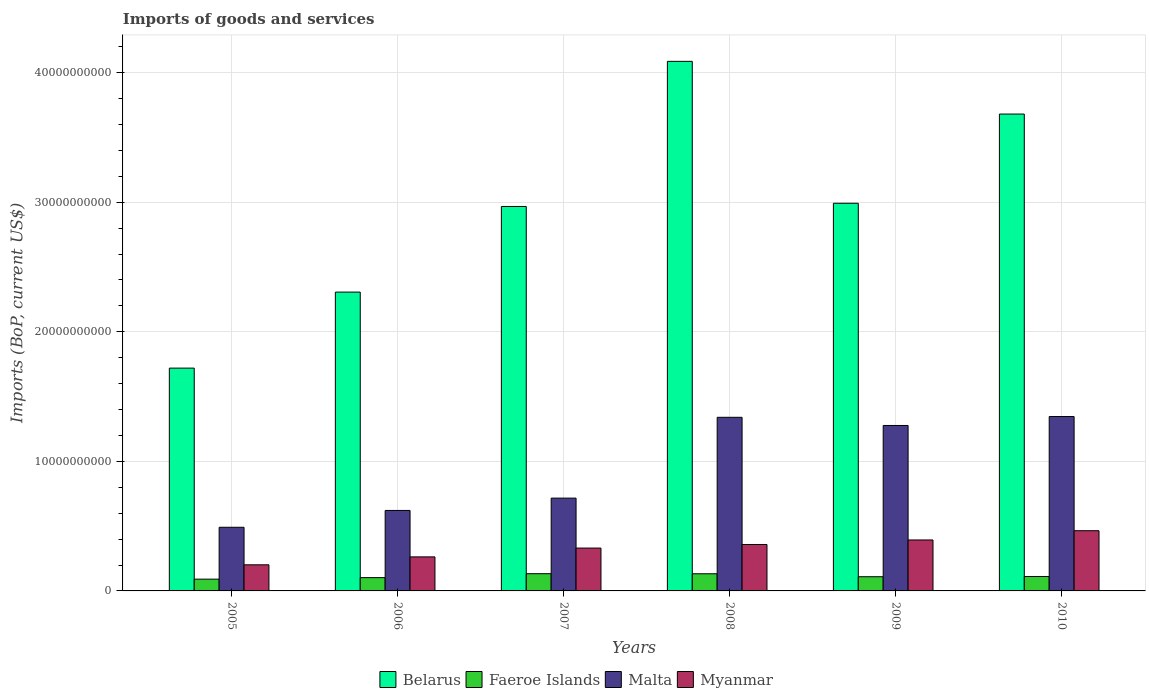How many different coloured bars are there?
Ensure brevity in your answer.  4. How many groups of bars are there?
Your answer should be very brief. 6. What is the label of the 6th group of bars from the left?
Your answer should be very brief. 2010. What is the amount spent on imports in Faeroe Islands in 2005?
Provide a short and direct response. 9.09e+08. Across all years, what is the maximum amount spent on imports in Faeroe Islands?
Your response must be concise. 1.33e+09. Across all years, what is the minimum amount spent on imports in Malta?
Give a very brief answer. 4.91e+09. In which year was the amount spent on imports in Malta maximum?
Provide a succinct answer. 2010. In which year was the amount spent on imports in Belarus minimum?
Your answer should be very brief. 2005. What is the total amount spent on imports in Myanmar in the graph?
Your answer should be compact. 2.01e+1. What is the difference between the amount spent on imports in Malta in 2005 and that in 2008?
Keep it short and to the point. -8.49e+09. What is the difference between the amount spent on imports in Myanmar in 2010 and the amount spent on imports in Malta in 2006?
Give a very brief answer. -1.56e+09. What is the average amount spent on imports in Belarus per year?
Make the answer very short. 2.96e+1. In the year 2006, what is the difference between the amount spent on imports in Myanmar and amount spent on imports in Faeroe Islands?
Ensure brevity in your answer.  1.60e+09. In how many years, is the amount spent on imports in Malta greater than 14000000000 US$?
Keep it short and to the point. 0. What is the ratio of the amount spent on imports in Malta in 2007 to that in 2009?
Ensure brevity in your answer.  0.56. Is the amount spent on imports in Belarus in 2007 less than that in 2010?
Your response must be concise. Yes. Is the difference between the amount spent on imports in Myanmar in 2008 and 2010 greater than the difference between the amount spent on imports in Faeroe Islands in 2008 and 2010?
Your response must be concise. No. What is the difference between the highest and the second highest amount spent on imports in Malta?
Provide a succinct answer. 5.88e+07. What is the difference between the highest and the lowest amount spent on imports in Myanmar?
Your answer should be very brief. 2.63e+09. Is it the case that in every year, the sum of the amount spent on imports in Belarus and amount spent on imports in Faeroe Islands is greater than the sum of amount spent on imports in Myanmar and amount spent on imports in Malta?
Ensure brevity in your answer.  Yes. What does the 2nd bar from the left in 2009 represents?
Your response must be concise. Faeroe Islands. What does the 1st bar from the right in 2005 represents?
Make the answer very short. Myanmar. How many bars are there?
Offer a very short reply. 24. Are the values on the major ticks of Y-axis written in scientific E-notation?
Provide a succinct answer. No. Does the graph contain any zero values?
Give a very brief answer. No. Does the graph contain grids?
Ensure brevity in your answer.  Yes. Where does the legend appear in the graph?
Provide a succinct answer. Bottom center. What is the title of the graph?
Ensure brevity in your answer.  Imports of goods and services. What is the label or title of the X-axis?
Provide a succinct answer. Years. What is the label or title of the Y-axis?
Provide a short and direct response. Imports (BoP, current US$). What is the Imports (BoP, current US$) of Belarus in 2005?
Give a very brief answer. 1.72e+1. What is the Imports (BoP, current US$) in Faeroe Islands in 2005?
Make the answer very short. 9.09e+08. What is the Imports (BoP, current US$) of Malta in 2005?
Offer a very short reply. 4.91e+09. What is the Imports (BoP, current US$) in Myanmar in 2005?
Provide a short and direct response. 2.02e+09. What is the Imports (BoP, current US$) in Belarus in 2006?
Make the answer very short. 2.31e+1. What is the Imports (BoP, current US$) of Faeroe Islands in 2006?
Your answer should be very brief. 1.03e+09. What is the Imports (BoP, current US$) of Malta in 2006?
Offer a very short reply. 6.21e+09. What is the Imports (BoP, current US$) in Myanmar in 2006?
Provide a succinct answer. 2.63e+09. What is the Imports (BoP, current US$) in Belarus in 2007?
Provide a succinct answer. 2.97e+1. What is the Imports (BoP, current US$) in Faeroe Islands in 2007?
Your response must be concise. 1.33e+09. What is the Imports (BoP, current US$) in Malta in 2007?
Provide a succinct answer. 7.16e+09. What is the Imports (BoP, current US$) in Myanmar in 2007?
Give a very brief answer. 3.31e+09. What is the Imports (BoP, current US$) of Belarus in 2008?
Your answer should be compact. 4.09e+1. What is the Imports (BoP, current US$) in Faeroe Islands in 2008?
Keep it short and to the point. 1.32e+09. What is the Imports (BoP, current US$) of Malta in 2008?
Give a very brief answer. 1.34e+1. What is the Imports (BoP, current US$) of Myanmar in 2008?
Keep it short and to the point. 3.58e+09. What is the Imports (BoP, current US$) of Belarus in 2009?
Give a very brief answer. 2.99e+1. What is the Imports (BoP, current US$) in Faeroe Islands in 2009?
Your answer should be very brief. 1.10e+09. What is the Imports (BoP, current US$) in Malta in 2009?
Your answer should be very brief. 1.28e+1. What is the Imports (BoP, current US$) of Myanmar in 2009?
Offer a terse response. 3.93e+09. What is the Imports (BoP, current US$) in Belarus in 2010?
Your answer should be very brief. 3.68e+1. What is the Imports (BoP, current US$) of Faeroe Islands in 2010?
Provide a succinct answer. 1.11e+09. What is the Imports (BoP, current US$) in Malta in 2010?
Your answer should be compact. 1.35e+1. What is the Imports (BoP, current US$) in Myanmar in 2010?
Your answer should be very brief. 4.65e+09. Across all years, what is the maximum Imports (BoP, current US$) of Belarus?
Provide a short and direct response. 4.09e+1. Across all years, what is the maximum Imports (BoP, current US$) of Faeroe Islands?
Your answer should be compact. 1.33e+09. Across all years, what is the maximum Imports (BoP, current US$) in Malta?
Provide a short and direct response. 1.35e+1. Across all years, what is the maximum Imports (BoP, current US$) in Myanmar?
Ensure brevity in your answer.  4.65e+09. Across all years, what is the minimum Imports (BoP, current US$) of Belarus?
Provide a short and direct response. 1.72e+1. Across all years, what is the minimum Imports (BoP, current US$) in Faeroe Islands?
Provide a short and direct response. 9.09e+08. Across all years, what is the minimum Imports (BoP, current US$) in Malta?
Make the answer very short. 4.91e+09. Across all years, what is the minimum Imports (BoP, current US$) in Myanmar?
Your response must be concise. 2.02e+09. What is the total Imports (BoP, current US$) of Belarus in the graph?
Your answer should be very brief. 1.78e+11. What is the total Imports (BoP, current US$) of Faeroe Islands in the graph?
Provide a succinct answer. 6.79e+09. What is the total Imports (BoP, current US$) in Malta in the graph?
Make the answer very short. 5.79e+1. What is the total Imports (BoP, current US$) in Myanmar in the graph?
Offer a very short reply. 2.01e+1. What is the difference between the Imports (BoP, current US$) of Belarus in 2005 and that in 2006?
Offer a terse response. -5.87e+09. What is the difference between the Imports (BoP, current US$) in Faeroe Islands in 2005 and that in 2006?
Provide a short and direct response. -1.17e+08. What is the difference between the Imports (BoP, current US$) in Malta in 2005 and that in 2006?
Your response must be concise. -1.30e+09. What is the difference between the Imports (BoP, current US$) in Myanmar in 2005 and that in 2006?
Your answer should be very brief. -6.11e+08. What is the difference between the Imports (BoP, current US$) in Belarus in 2005 and that in 2007?
Your answer should be very brief. -1.25e+1. What is the difference between the Imports (BoP, current US$) of Faeroe Islands in 2005 and that in 2007?
Your answer should be compact. -4.21e+08. What is the difference between the Imports (BoP, current US$) of Malta in 2005 and that in 2007?
Provide a short and direct response. -2.25e+09. What is the difference between the Imports (BoP, current US$) in Myanmar in 2005 and that in 2007?
Provide a succinct answer. -1.29e+09. What is the difference between the Imports (BoP, current US$) of Belarus in 2005 and that in 2008?
Your answer should be compact. -2.37e+1. What is the difference between the Imports (BoP, current US$) in Faeroe Islands in 2005 and that in 2008?
Provide a short and direct response. -4.15e+08. What is the difference between the Imports (BoP, current US$) of Malta in 2005 and that in 2008?
Your answer should be very brief. -8.49e+09. What is the difference between the Imports (BoP, current US$) in Myanmar in 2005 and that in 2008?
Your response must be concise. -1.57e+09. What is the difference between the Imports (BoP, current US$) of Belarus in 2005 and that in 2009?
Offer a very short reply. -1.27e+1. What is the difference between the Imports (BoP, current US$) of Faeroe Islands in 2005 and that in 2009?
Keep it short and to the point. -1.87e+08. What is the difference between the Imports (BoP, current US$) of Malta in 2005 and that in 2009?
Make the answer very short. -7.86e+09. What is the difference between the Imports (BoP, current US$) in Myanmar in 2005 and that in 2009?
Your answer should be compact. -1.92e+09. What is the difference between the Imports (BoP, current US$) in Belarus in 2005 and that in 2010?
Give a very brief answer. -1.96e+1. What is the difference between the Imports (BoP, current US$) in Faeroe Islands in 2005 and that in 2010?
Provide a short and direct response. -2.02e+08. What is the difference between the Imports (BoP, current US$) in Malta in 2005 and that in 2010?
Provide a short and direct response. -8.55e+09. What is the difference between the Imports (BoP, current US$) in Myanmar in 2005 and that in 2010?
Keep it short and to the point. -2.63e+09. What is the difference between the Imports (BoP, current US$) of Belarus in 2006 and that in 2007?
Keep it short and to the point. -6.61e+09. What is the difference between the Imports (BoP, current US$) in Faeroe Islands in 2006 and that in 2007?
Keep it short and to the point. -3.04e+08. What is the difference between the Imports (BoP, current US$) of Malta in 2006 and that in 2007?
Offer a very short reply. -9.52e+08. What is the difference between the Imports (BoP, current US$) of Myanmar in 2006 and that in 2007?
Offer a terse response. -6.80e+08. What is the difference between the Imports (BoP, current US$) in Belarus in 2006 and that in 2008?
Provide a short and direct response. -1.78e+1. What is the difference between the Imports (BoP, current US$) in Faeroe Islands in 2006 and that in 2008?
Offer a very short reply. -2.98e+08. What is the difference between the Imports (BoP, current US$) of Malta in 2006 and that in 2008?
Your answer should be very brief. -7.19e+09. What is the difference between the Imports (BoP, current US$) of Myanmar in 2006 and that in 2008?
Offer a terse response. -9.56e+08. What is the difference between the Imports (BoP, current US$) in Belarus in 2006 and that in 2009?
Offer a terse response. -6.86e+09. What is the difference between the Imports (BoP, current US$) of Faeroe Islands in 2006 and that in 2009?
Your response must be concise. -6.97e+07. What is the difference between the Imports (BoP, current US$) in Malta in 2006 and that in 2009?
Make the answer very short. -6.56e+09. What is the difference between the Imports (BoP, current US$) of Myanmar in 2006 and that in 2009?
Your answer should be compact. -1.31e+09. What is the difference between the Imports (BoP, current US$) of Belarus in 2006 and that in 2010?
Keep it short and to the point. -1.37e+1. What is the difference between the Imports (BoP, current US$) in Faeroe Islands in 2006 and that in 2010?
Ensure brevity in your answer.  -8.53e+07. What is the difference between the Imports (BoP, current US$) of Malta in 2006 and that in 2010?
Ensure brevity in your answer.  -7.25e+09. What is the difference between the Imports (BoP, current US$) of Myanmar in 2006 and that in 2010?
Keep it short and to the point. -2.02e+09. What is the difference between the Imports (BoP, current US$) in Belarus in 2007 and that in 2008?
Your answer should be very brief. -1.12e+1. What is the difference between the Imports (BoP, current US$) of Faeroe Islands in 2007 and that in 2008?
Offer a terse response. 6.06e+06. What is the difference between the Imports (BoP, current US$) of Malta in 2007 and that in 2008?
Give a very brief answer. -6.24e+09. What is the difference between the Imports (BoP, current US$) in Myanmar in 2007 and that in 2008?
Ensure brevity in your answer.  -2.76e+08. What is the difference between the Imports (BoP, current US$) of Belarus in 2007 and that in 2009?
Give a very brief answer. -2.49e+08. What is the difference between the Imports (BoP, current US$) in Faeroe Islands in 2007 and that in 2009?
Your answer should be compact. 2.35e+08. What is the difference between the Imports (BoP, current US$) of Malta in 2007 and that in 2009?
Offer a very short reply. -5.61e+09. What is the difference between the Imports (BoP, current US$) in Myanmar in 2007 and that in 2009?
Offer a very short reply. -6.26e+08. What is the difference between the Imports (BoP, current US$) in Belarus in 2007 and that in 2010?
Your answer should be very brief. -7.13e+09. What is the difference between the Imports (BoP, current US$) of Faeroe Islands in 2007 and that in 2010?
Provide a short and direct response. 2.19e+08. What is the difference between the Imports (BoP, current US$) of Malta in 2007 and that in 2010?
Provide a short and direct response. -6.30e+09. What is the difference between the Imports (BoP, current US$) in Myanmar in 2007 and that in 2010?
Keep it short and to the point. -1.34e+09. What is the difference between the Imports (BoP, current US$) of Belarus in 2008 and that in 2009?
Your response must be concise. 1.10e+1. What is the difference between the Imports (BoP, current US$) in Faeroe Islands in 2008 and that in 2009?
Offer a terse response. 2.29e+08. What is the difference between the Imports (BoP, current US$) in Malta in 2008 and that in 2009?
Offer a terse response. 6.31e+08. What is the difference between the Imports (BoP, current US$) of Myanmar in 2008 and that in 2009?
Your response must be concise. -3.50e+08. What is the difference between the Imports (BoP, current US$) of Belarus in 2008 and that in 2010?
Your answer should be compact. 4.07e+09. What is the difference between the Imports (BoP, current US$) in Faeroe Islands in 2008 and that in 2010?
Give a very brief answer. 2.13e+08. What is the difference between the Imports (BoP, current US$) in Malta in 2008 and that in 2010?
Ensure brevity in your answer.  -5.88e+07. What is the difference between the Imports (BoP, current US$) in Myanmar in 2008 and that in 2010?
Give a very brief answer. -1.06e+09. What is the difference between the Imports (BoP, current US$) of Belarus in 2009 and that in 2010?
Your answer should be compact. -6.88e+09. What is the difference between the Imports (BoP, current US$) in Faeroe Islands in 2009 and that in 2010?
Offer a terse response. -1.55e+07. What is the difference between the Imports (BoP, current US$) of Malta in 2009 and that in 2010?
Provide a succinct answer. -6.89e+08. What is the difference between the Imports (BoP, current US$) of Myanmar in 2009 and that in 2010?
Keep it short and to the point. -7.14e+08. What is the difference between the Imports (BoP, current US$) of Belarus in 2005 and the Imports (BoP, current US$) of Faeroe Islands in 2006?
Keep it short and to the point. 1.62e+1. What is the difference between the Imports (BoP, current US$) of Belarus in 2005 and the Imports (BoP, current US$) of Malta in 2006?
Provide a short and direct response. 1.10e+1. What is the difference between the Imports (BoP, current US$) in Belarus in 2005 and the Imports (BoP, current US$) in Myanmar in 2006?
Keep it short and to the point. 1.46e+1. What is the difference between the Imports (BoP, current US$) in Faeroe Islands in 2005 and the Imports (BoP, current US$) in Malta in 2006?
Offer a very short reply. -5.30e+09. What is the difference between the Imports (BoP, current US$) in Faeroe Islands in 2005 and the Imports (BoP, current US$) in Myanmar in 2006?
Keep it short and to the point. -1.72e+09. What is the difference between the Imports (BoP, current US$) in Malta in 2005 and the Imports (BoP, current US$) in Myanmar in 2006?
Give a very brief answer. 2.29e+09. What is the difference between the Imports (BoP, current US$) of Belarus in 2005 and the Imports (BoP, current US$) of Faeroe Islands in 2007?
Your response must be concise. 1.59e+1. What is the difference between the Imports (BoP, current US$) in Belarus in 2005 and the Imports (BoP, current US$) in Malta in 2007?
Your answer should be compact. 1.00e+1. What is the difference between the Imports (BoP, current US$) of Belarus in 2005 and the Imports (BoP, current US$) of Myanmar in 2007?
Make the answer very short. 1.39e+1. What is the difference between the Imports (BoP, current US$) in Faeroe Islands in 2005 and the Imports (BoP, current US$) in Malta in 2007?
Provide a short and direct response. -6.25e+09. What is the difference between the Imports (BoP, current US$) of Faeroe Islands in 2005 and the Imports (BoP, current US$) of Myanmar in 2007?
Offer a very short reply. -2.40e+09. What is the difference between the Imports (BoP, current US$) of Malta in 2005 and the Imports (BoP, current US$) of Myanmar in 2007?
Your answer should be compact. 1.61e+09. What is the difference between the Imports (BoP, current US$) of Belarus in 2005 and the Imports (BoP, current US$) of Faeroe Islands in 2008?
Provide a succinct answer. 1.59e+1. What is the difference between the Imports (BoP, current US$) in Belarus in 2005 and the Imports (BoP, current US$) in Malta in 2008?
Offer a terse response. 3.80e+09. What is the difference between the Imports (BoP, current US$) of Belarus in 2005 and the Imports (BoP, current US$) of Myanmar in 2008?
Offer a terse response. 1.36e+1. What is the difference between the Imports (BoP, current US$) in Faeroe Islands in 2005 and the Imports (BoP, current US$) in Malta in 2008?
Your response must be concise. -1.25e+1. What is the difference between the Imports (BoP, current US$) of Faeroe Islands in 2005 and the Imports (BoP, current US$) of Myanmar in 2008?
Offer a very short reply. -2.67e+09. What is the difference between the Imports (BoP, current US$) in Malta in 2005 and the Imports (BoP, current US$) in Myanmar in 2008?
Offer a terse response. 1.33e+09. What is the difference between the Imports (BoP, current US$) of Belarus in 2005 and the Imports (BoP, current US$) of Faeroe Islands in 2009?
Make the answer very short. 1.61e+1. What is the difference between the Imports (BoP, current US$) in Belarus in 2005 and the Imports (BoP, current US$) in Malta in 2009?
Your answer should be compact. 4.43e+09. What is the difference between the Imports (BoP, current US$) in Belarus in 2005 and the Imports (BoP, current US$) in Myanmar in 2009?
Keep it short and to the point. 1.33e+1. What is the difference between the Imports (BoP, current US$) of Faeroe Islands in 2005 and the Imports (BoP, current US$) of Malta in 2009?
Your response must be concise. -1.19e+1. What is the difference between the Imports (BoP, current US$) of Faeroe Islands in 2005 and the Imports (BoP, current US$) of Myanmar in 2009?
Provide a succinct answer. -3.02e+09. What is the difference between the Imports (BoP, current US$) of Malta in 2005 and the Imports (BoP, current US$) of Myanmar in 2009?
Keep it short and to the point. 9.80e+08. What is the difference between the Imports (BoP, current US$) of Belarus in 2005 and the Imports (BoP, current US$) of Faeroe Islands in 2010?
Your answer should be compact. 1.61e+1. What is the difference between the Imports (BoP, current US$) of Belarus in 2005 and the Imports (BoP, current US$) of Malta in 2010?
Keep it short and to the point. 3.74e+09. What is the difference between the Imports (BoP, current US$) in Belarus in 2005 and the Imports (BoP, current US$) in Myanmar in 2010?
Make the answer very short. 1.25e+1. What is the difference between the Imports (BoP, current US$) in Faeroe Islands in 2005 and the Imports (BoP, current US$) in Malta in 2010?
Give a very brief answer. -1.25e+1. What is the difference between the Imports (BoP, current US$) of Faeroe Islands in 2005 and the Imports (BoP, current US$) of Myanmar in 2010?
Provide a short and direct response. -3.74e+09. What is the difference between the Imports (BoP, current US$) in Malta in 2005 and the Imports (BoP, current US$) in Myanmar in 2010?
Your answer should be very brief. 2.66e+08. What is the difference between the Imports (BoP, current US$) of Belarus in 2006 and the Imports (BoP, current US$) of Faeroe Islands in 2007?
Provide a succinct answer. 2.17e+1. What is the difference between the Imports (BoP, current US$) in Belarus in 2006 and the Imports (BoP, current US$) in Malta in 2007?
Your answer should be compact. 1.59e+1. What is the difference between the Imports (BoP, current US$) in Belarus in 2006 and the Imports (BoP, current US$) in Myanmar in 2007?
Provide a short and direct response. 1.98e+1. What is the difference between the Imports (BoP, current US$) of Faeroe Islands in 2006 and the Imports (BoP, current US$) of Malta in 2007?
Your answer should be very brief. -6.14e+09. What is the difference between the Imports (BoP, current US$) in Faeroe Islands in 2006 and the Imports (BoP, current US$) in Myanmar in 2007?
Give a very brief answer. -2.28e+09. What is the difference between the Imports (BoP, current US$) in Malta in 2006 and the Imports (BoP, current US$) in Myanmar in 2007?
Offer a terse response. 2.90e+09. What is the difference between the Imports (BoP, current US$) of Belarus in 2006 and the Imports (BoP, current US$) of Faeroe Islands in 2008?
Ensure brevity in your answer.  2.17e+1. What is the difference between the Imports (BoP, current US$) of Belarus in 2006 and the Imports (BoP, current US$) of Malta in 2008?
Your answer should be compact. 9.66e+09. What is the difference between the Imports (BoP, current US$) of Belarus in 2006 and the Imports (BoP, current US$) of Myanmar in 2008?
Provide a succinct answer. 1.95e+1. What is the difference between the Imports (BoP, current US$) in Faeroe Islands in 2006 and the Imports (BoP, current US$) in Malta in 2008?
Offer a terse response. -1.24e+1. What is the difference between the Imports (BoP, current US$) of Faeroe Islands in 2006 and the Imports (BoP, current US$) of Myanmar in 2008?
Offer a terse response. -2.56e+09. What is the difference between the Imports (BoP, current US$) in Malta in 2006 and the Imports (BoP, current US$) in Myanmar in 2008?
Provide a succinct answer. 2.63e+09. What is the difference between the Imports (BoP, current US$) of Belarus in 2006 and the Imports (BoP, current US$) of Faeroe Islands in 2009?
Your response must be concise. 2.20e+1. What is the difference between the Imports (BoP, current US$) of Belarus in 2006 and the Imports (BoP, current US$) of Malta in 2009?
Give a very brief answer. 1.03e+1. What is the difference between the Imports (BoP, current US$) in Belarus in 2006 and the Imports (BoP, current US$) in Myanmar in 2009?
Your answer should be compact. 1.91e+1. What is the difference between the Imports (BoP, current US$) in Faeroe Islands in 2006 and the Imports (BoP, current US$) in Malta in 2009?
Offer a terse response. -1.17e+1. What is the difference between the Imports (BoP, current US$) in Faeroe Islands in 2006 and the Imports (BoP, current US$) in Myanmar in 2009?
Make the answer very short. -2.91e+09. What is the difference between the Imports (BoP, current US$) of Malta in 2006 and the Imports (BoP, current US$) of Myanmar in 2009?
Provide a succinct answer. 2.28e+09. What is the difference between the Imports (BoP, current US$) of Belarus in 2006 and the Imports (BoP, current US$) of Faeroe Islands in 2010?
Offer a terse response. 2.20e+1. What is the difference between the Imports (BoP, current US$) in Belarus in 2006 and the Imports (BoP, current US$) in Malta in 2010?
Your answer should be very brief. 9.60e+09. What is the difference between the Imports (BoP, current US$) in Belarus in 2006 and the Imports (BoP, current US$) in Myanmar in 2010?
Offer a very short reply. 1.84e+1. What is the difference between the Imports (BoP, current US$) of Faeroe Islands in 2006 and the Imports (BoP, current US$) of Malta in 2010?
Provide a succinct answer. -1.24e+1. What is the difference between the Imports (BoP, current US$) in Faeroe Islands in 2006 and the Imports (BoP, current US$) in Myanmar in 2010?
Your answer should be very brief. -3.62e+09. What is the difference between the Imports (BoP, current US$) of Malta in 2006 and the Imports (BoP, current US$) of Myanmar in 2010?
Ensure brevity in your answer.  1.56e+09. What is the difference between the Imports (BoP, current US$) of Belarus in 2007 and the Imports (BoP, current US$) of Faeroe Islands in 2008?
Give a very brief answer. 2.83e+1. What is the difference between the Imports (BoP, current US$) of Belarus in 2007 and the Imports (BoP, current US$) of Malta in 2008?
Make the answer very short. 1.63e+1. What is the difference between the Imports (BoP, current US$) in Belarus in 2007 and the Imports (BoP, current US$) in Myanmar in 2008?
Provide a short and direct response. 2.61e+1. What is the difference between the Imports (BoP, current US$) in Faeroe Islands in 2007 and the Imports (BoP, current US$) in Malta in 2008?
Provide a succinct answer. -1.21e+1. What is the difference between the Imports (BoP, current US$) in Faeroe Islands in 2007 and the Imports (BoP, current US$) in Myanmar in 2008?
Your response must be concise. -2.25e+09. What is the difference between the Imports (BoP, current US$) of Malta in 2007 and the Imports (BoP, current US$) of Myanmar in 2008?
Provide a succinct answer. 3.58e+09. What is the difference between the Imports (BoP, current US$) of Belarus in 2007 and the Imports (BoP, current US$) of Faeroe Islands in 2009?
Offer a very short reply. 2.86e+1. What is the difference between the Imports (BoP, current US$) in Belarus in 2007 and the Imports (BoP, current US$) in Malta in 2009?
Give a very brief answer. 1.69e+1. What is the difference between the Imports (BoP, current US$) of Belarus in 2007 and the Imports (BoP, current US$) of Myanmar in 2009?
Your response must be concise. 2.57e+1. What is the difference between the Imports (BoP, current US$) in Faeroe Islands in 2007 and the Imports (BoP, current US$) in Malta in 2009?
Offer a very short reply. -1.14e+1. What is the difference between the Imports (BoP, current US$) in Faeroe Islands in 2007 and the Imports (BoP, current US$) in Myanmar in 2009?
Give a very brief answer. -2.60e+09. What is the difference between the Imports (BoP, current US$) of Malta in 2007 and the Imports (BoP, current US$) of Myanmar in 2009?
Ensure brevity in your answer.  3.23e+09. What is the difference between the Imports (BoP, current US$) in Belarus in 2007 and the Imports (BoP, current US$) in Faeroe Islands in 2010?
Provide a succinct answer. 2.86e+1. What is the difference between the Imports (BoP, current US$) of Belarus in 2007 and the Imports (BoP, current US$) of Malta in 2010?
Provide a succinct answer. 1.62e+1. What is the difference between the Imports (BoP, current US$) in Belarus in 2007 and the Imports (BoP, current US$) in Myanmar in 2010?
Keep it short and to the point. 2.50e+1. What is the difference between the Imports (BoP, current US$) of Faeroe Islands in 2007 and the Imports (BoP, current US$) of Malta in 2010?
Your response must be concise. -1.21e+1. What is the difference between the Imports (BoP, current US$) of Faeroe Islands in 2007 and the Imports (BoP, current US$) of Myanmar in 2010?
Offer a terse response. -3.32e+09. What is the difference between the Imports (BoP, current US$) of Malta in 2007 and the Imports (BoP, current US$) of Myanmar in 2010?
Make the answer very short. 2.52e+09. What is the difference between the Imports (BoP, current US$) of Belarus in 2008 and the Imports (BoP, current US$) of Faeroe Islands in 2009?
Provide a short and direct response. 3.98e+1. What is the difference between the Imports (BoP, current US$) in Belarus in 2008 and the Imports (BoP, current US$) in Malta in 2009?
Keep it short and to the point. 2.81e+1. What is the difference between the Imports (BoP, current US$) of Belarus in 2008 and the Imports (BoP, current US$) of Myanmar in 2009?
Make the answer very short. 3.69e+1. What is the difference between the Imports (BoP, current US$) in Faeroe Islands in 2008 and the Imports (BoP, current US$) in Malta in 2009?
Offer a terse response. -1.14e+1. What is the difference between the Imports (BoP, current US$) of Faeroe Islands in 2008 and the Imports (BoP, current US$) of Myanmar in 2009?
Make the answer very short. -2.61e+09. What is the difference between the Imports (BoP, current US$) in Malta in 2008 and the Imports (BoP, current US$) in Myanmar in 2009?
Your answer should be very brief. 9.47e+09. What is the difference between the Imports (BoP, current US$) in Belarus in 2008 and the Imports (BoP, current US$) in Faeroe Islands in 2010?
Provide a short and direct response. 3.98e+1. What is the difference between the Imports (BoP, current US$) of Belarus in 2008 and the Imports (BoP, current US$) of Malta in 2010?
Give a very brief answer. 2.74e+1. What is the difference between the Imports (BoP, current US$) in Belarus in 2008 and the Imports (BoP, current US$) in Myanmar in 2010?
Provide a short and direct response. 3.62e+1. What is the difference between the Imports (BoP, current US$) in Faeroe Islands in 2008 and the Imports (BoP, current US$) in Malta in 2010?
Your answer should be very brief. -1.21e+1. What is the difference between the Imports (BoP, current US$) in Faeroe Islands in 2008 and the Imports (BoP, current US$) in Myanmar in 2010?
Make the answer very short. -3.32e+09. What is the difference between the Imports (BoP, current US$) of Malta in 2008 and the Imports (BoP, current US$) of Myanmar in 2010?
Your response must be concise. 8.75e+09. What is the difference between the Imports (BoP, current US$) of Belarus in 2009 and the Imports (BoP, current US$) of Faeroe Islands in 2010?
Provide a short and direct response. 2.88e+1. What is the difference between the Imports (BoP, current US$) of Belarus in 2009 and the Imports (BoP, current US$) of Malta in 2010?
Ensure brevity in your answer.  1.65e+1. What is the difference between the Imports (BoP, current US$) in Belarus in 2009 and the Imports (BoP, current US$) in Myanmar in 2010?
Keep it short and to the point. 2.53e+1. What is the difference between the Imports (BoP, current US$) in Faeroe Islands in 2009 and the Imports (BoP, current US$) in Malta in 2010?
Ensure brevity in your answer.  -1.24e+1. What is the difference between the Imports (BoP, current US$) in Faeroe Islands in 2009 and the Imports (BoP, current US$) in Myanmar in 2010?
Give a very brief answer. -3.55e+09. What is the difference between the Imports (BoP, current US$) of Malta in 2009 and the Imports (BoP, current US$) of Myanmar in 2010?
Make the answer very short. 8.12e+09. What is the average Imports (BoP, current US$) of Belarus per year?
Your answer should be very brief. 2.96e+1. What is the average Imports (BoP, current US$) in Faeroe Islands per year?
Give a very brief answer. 1.13e+09. What is the average Imports (BoP, current US$) in Malta per year?
Your answer should be compact. 9.65e+09. What is the average Imports (BoP, current US$) of Myanmar per year?
Keep it short and to the point. 3.35e+09. In the year 2005, what is the difference between the Imports (BoP, current US$) in Belarus and Imports (BoP, current US$) in Faeroe Islands?
Offer a terse response. 1.63e+1. In the year 2005, what is the difference between the Imports (BoP, current US$) of Belarus and Imports (BoP, current US$) of Malta?
Make the answer very short. 1.23e+1. In the year 2005, what is the difference between the Imports (BoP, current US$) in Belarus and Imports (BoP, current US$) in Myanmar?
Provide a short and direct response. 1.52e+1. In the year 2005, what is the difference between the Imports (BoP, current US$) in Faeroe Islands and Imports (BoP, current US$) in Malta?
Your answer should be very brief. -4.00e+09. In the year 2005, what is the difference between the Imports (BoP, current US$) in Faeroe Islands and Imports (BoP, current US$) in Myanmar?
Your answer should be very brief. -1.11e+09. In the year 2005, what is the difference between the Imports (BoP, current US$) of Malta and Imports (BoP, current US$) of Myanmar?
Keep it short and to the point. 2.90e+09. In the year 2006, what is the difference between the Imports (BoP, current US$) of Belarus and Imports (BoP, current US$) of Faeroe Islands?
Your answer should be compact. 2.20e+1. In the year 2006, what is the difference between the Imports (BoP, current US$) in Belarus and Imports (BoP, current US$) in Malta?
Provide a succinct answer. 1.69e+1. In the year 2006, what is the difference between the Imports (BoP, current US$) of Belarus and Imports (BoP, current US$) of Myanmar?
Your answer should be compact. 2.04e+1. In the year 2006, what is the difference between the Imports (BoP, current US$) in Faeroe Islands and Imports (BoP, current US$) in Malta?
Provide a succinct answer. -5.18e+09. In the year 2006, what is the difference between the Imports (BoP, current US$) of Faeroe Islands and Imports (BoP, current US$) of Myanmar?
Keep it short and to the point. -1.60e+09. In the year 2006, what is the difference between the Imports (BoP, current US$) in Malta and Imports (BoP, current US$) in Myanmar?
Your answer should be compact. 3.58e+09. In the year 2007, what is the difference between the Imports (BoP, current US$) of Belarus and Imports (BoP, current US$) of Faeroe Islands?
Offer a very short reply. 2.83e+1. In the year 2007, what is the difference between the Imports (BoP, current US$) of Belarus and Imports (BoP, current US$) of Malta?
Offer a terse response. 2.25e+1. In the year 2007, what is the difference between the Imports (BoP, current US$) of Belarus and Imports (BoP, current US$) of Myanmar?
Keep it short and to the point. 2.64e+1. In the year 2007, what is the difference between the Imports (BoP, current US$) in Faeroe Islands and Imports (BoP, current US$) in Malta?
Offer a very short reply. -5.83e+09. In the year 2007, what is the difference between the Imports (BoP, current US$) in Faeroe Islands and Imports (BoP, current US$) in Myanmar?
Keep it short and to the point. -1.98e+09. In the year 2007, what is the difference between the Imports (BoP, current US$) in Malta and Imports (BoP, current US$) in Myanmar?
Offer a very short reply. 3.86e+09. In the year 2008, what is the difference between the Imports (BoP, current US$) of Belarus and Imports (BoP, current US$) of Faeroe Islands?
Make the answer very short. 3.95e+1. In the year 2008, what is the difference between the Imports (BoP, current US$) of Belarus and Imports (BoP, current US$) of Malta?
Your response must be concise. 2.75e+1. In the year 2008, what is the difference between the Imports (BoP, current US$) of Belarus and Imports (BoP, current US$) of Myanmar?
Provide a short and direct response. 3.73e+1. In the year 2008, what is the difference between the Imports (BoP, current US$) in Faeroe Islands and Imports (BoP, current US$) in Malta?
Keep it short and to the point. -1.21e+1. In the year 2008, what is the difference between the Imports (BoP, current US$) of Faeroe Islands and Imports (BoP, current US$) of Myanmar?
Provide a short and direct response. -2.26e+09. In the year 2008, what is the difference between the Imports (BoP, current US$) of Malta and Imports (BoP, current US$) of Myanmar?
Your answer should be compact. 9.82e+09. In the year 2009, what is the difference between the Imports (BoP, current US$) of Belarus and Imports (BoP, current US$) of Faeroe Islands?
Provide a short and direct response. 2.88e+1. In the year 2009, what is the difference between the Imports (BoP, current US$) of Belarus and Imports (BoP, current US$) of Malta?
Your response must be concise. 1.72e+1. In the year 2009, what is the difference between the Imports (BoP, current US$) of Belarus and Imports (BoP, current US$) of Myanmar?
Your response must be concise. 2.60e+1. In the year 2009, what is the difference between the Imports (BoP, current US$) in Faeroe Islands and Imports (BoP, current US$) in Malta?
Keep it short and to the point. -1.17e+1. In the year 2009, what is the difference between the Imports (BoP, current US$) in Faeroe Islands and Imports (BoP, current US$) in Myanmar?
Your response must be concise. -2.84e+09. In the year 2009, what is the difference between the Imports (BoP, current US$) of Malta and Imports (BoP, current US$) of Myanmar?
Keep it short and to the point. 8.84e+09. In the year 2010, what is the difference between the Imports (BoP, current US$) in Belarus and Imports (BoP, current US$) in Faeroe Islands?
Your response must be concise. 3.57e+1. In the year 2010, what is the difference between the Imports (BoP, current US$) in Belarus and Imports (BoP, current US$) in Malta?
Your answer should be compact. 2.33e+1. In the year 2010, what is the difference between the Imports (BoP, current US$) of Belarus and Imports (BoP, current US$) of Myanmar?
Offer a terse response. 3.22e+1. In the year 2010, what is the difference between the Imports (BoP, current US$) in Faeroe Islands and Imports (BoP, current US$) in Malta?
Offer a very short reply. -1.23e+1. In the year 2010, what is the difference between the Imports (BoP, current US$) of Faeroe Islands and Imports (BoP, current US$) of Myanmar?
Offer a very short reply. -3.54e+09. In the year 2010, what is the difference between the Imports (BoP, current US$) in Malta and Imports (BoP, current US$) in Myanmar?
Your answer should be compact. 8.81e+09. What is the ratio of the Imports (BoP, current US$) of Belarus in 2005 to that in 2006?
Ensure brevity in your answer.  0.75. What is the ratio of the Imports (BoP, current US$) in Faeroe Islands in 2005 to that in 2006?
Give a very brief answer. 0.89. What is the ratio of the Imports (BoP, current US$) in Malta in 2005 to that in 2006?
Provide a short and direct response. 0.79. What is the ratio of the Imports (BoP, current US$) in Myanmar in 2005 to that in 2006?
Offer a very short reply. 0.77. What is the ratio of the Imports (BoP, current US$) in Belarus in 2005 to that in 2007?
Provide a succinct answer. 0.58. What is the ratio of the Imports (BoP, current US$) of Faeroe Islands in 2005 to that in 2007?
Keep it short and to the point. 0.68. What is the ratio of the Imports (BoP, current US$) in Malta in 2005 to that in 2007?
Provide a short and direct response. 0.69. What is the ratio of the Imports (BoP, current US$) of Myanmar in 2005 to that in 2007?
Offer a very short reply. 0.61. What is the ratio of the Imports (BoP, current US$) of Belarus in 2005 to that in 2008?
Your response must be concise. 0.42. What is the ratio of the Imports (BoP, current US$) of Faeroe Islands in 2005 to that in 2008?
Provide a succinct answer. 0.69. What is the ratio of the Imports (BoP, current US$) of Malta in 2005 to that in 2008?
Provide a short and direct response. 0.37. What is the ratio of the Imports (BoP, current US$) in Myanmar in 2005 to that in 2008?
Your answer should be very brief. 0.56. What is the ratio of the Imports (BoP, current US$) of Belarus in 2005 to that in 2009?
Your answer should be very brief. 0.57. What is the ratio of the Imports (BoP, current US$) in Faeroe Islands in 2005 to that in 2009?
Provide a short and direct response. 0.83. What is the ratio of the Imports (BoP, current US$) of Malta in 2005 to that in 2009?
Make the answer very short. 0.38. What is the ratio of the Imports (BoP, current US$) in Myanmar in 2005 to that in 2009?
Make the answer very short. 0.51. What is the ratio of the Imports (BoP, current US$) in Belarus in 2005 to that in 2010?
Your response must be concise. 0.47. What is the ratio of the Imports (BoP, current US$) in Faeroe Islands in 2005 to that in 2010?
Your answer should be compact. 0.82. What is the ratio of the Imports (BoP, current US$) in Malta in 2005 to that in 2010?
Offer a very short reply. 0.36. What is the ratio of the Imports (BoP, current US$) of Myanmar in 2005 to that in 2010?
Give a very brief answer. 0.43. What is the ratio of the Imports (BoP, current US$) of Belarus in 2006 to that in 2007?
Keep it short and to the point. 0.78. What is the ratio of the Imports (BoP, current US$) in Faeroe Islands in 2006 to that in 2007?
Ensure brevity in your answer.  0.77. What is the ratio of the Imports (BoP, current US$) of Malta in 2006 to that in 2007?
Provide a succinct answer. 0.87. What is the ratio of the Imports (BoP, current US$) in Myanmar in 2006 to that in 2007?
Your answer should be compact. 0.79. What is the ratio of the Imports (BoP, current US$) in Belarus in 2006 to that in 2008?
Your answer should be compact. 0.56. What is the ratio of the Imports (BoP, current US$) in Faeroe Islands in 2006 to that in 2008?
Provide a short and direct response. 0.77. What is the ratio of the Imports (BoP, current US$) of Malta in 2006 to that in 2008?
Keep it short and to the point. 0.46. What is the ratio of the Imports (BoP, current US$) in Myanmar in 2006 to that in 2008?
Give a very brief answer. 0.73. What is the ratio of the Imports (BoP, current US$) in Belarus in 2006 to that in 2009?
Keep it short and to the point. 0.77. What is the ratio of the Imports (BoP, current US$) in Faeroe Islands in 2006 to that in 2009?
Keep it short and to the point. 0.94. What is the ratio of the Imports (BoP, current US$) of Malta in 2006 to that in 2009?
Your response must be concise. 0.49. What is the ratio of the Imports (BoP, current US$) in Myanmar in 2006 to that in 2009?
Make the answer very short. 0.67. What is the ratio of the Imports (BoP, current US$) in Belarus in 2006 to that in 2010?
Your answer should be compact. 0.63. What is the ratio of the Imports (BoP, current US$) in Faeroe Islands in 2006 to that in 2010?
Your answer should be very brief. 0.92. What is the ratio of the Imports (BoP, current US$) in Malta in 2006 to that in 2010?
Make the answer very short. 0.46. What is the ratio of the Imports (BoP, current US$) in Myanmar in 2006 to that in 2010?
Provide a succinct answer. 0.57. What is the ratio of the Imports (BoP, current US$) of Belarus in 2007 to that in 2008?
Provide a succinct answer. 0.73. What is the ratio of the Imports (BoP, current US$) of Faeroe Islands in 2007 to that in 2008?
Make the answer very short. 1. What is the ratio of the Imports (BoP, current US$) in Malta in 2007 to that in 2008?
Offer a terse response. 0.53. What is the ratio of the Imports (BoP, current US$) in Myanmar in 2007 to that in 2008?
Offer a terse response. 0.92. What is the ratio of the Imports (BoP, current US$) in Belarus in 2007 to that in 2009?
Ensure brevity in your answer.  0.99. What is the ratio of the Imports (BoP, current US$) of Faeroe Islands in 2007 to that in 2009?
Provide a succinct answer. 1.21. What is the ratio of the Imports (BoP, current US$) of Malta in 2007 to that in 2009?
Provide a succinct answer. 0.56. What is the ratio of the Imports (BoP, current US$) in Myanmar in 2007 to that in 2009?
Offer a terse response. 0.84. What is the ratio of the Imports (BoP, current US$) in Belarus in 2007 to that in 2010?
Ensure brevity in your answer.  0.81. What is the ratio of the Imports (BoP, current US$) of Faeroe Islands in 2007 to that in 2010?
Provide a short and direct response. 1.2. What is the ratio of the Imports (BoP, current US$) in Malta in 2007 to that in 2010?
Keep it short and to the point. 0.53. What is the ratio of the Imports (BoP, current US$) in Myanmar in 2007 to that in 2010?
Give a very brief answer. 0.71. What is the ratio of the Imports (BoP, current US$) in Belarus in 2008 to that in 2009?
Your response must be concise. 1.37. What is the ratio of the Imports (BoP, current US$) in Faeroe Islands in 2008 to that in 2009?
Your response must be concise. 1.21. What is the ratio of the Imports (BoP, current US$) in Malta in 2008 to that in 2009?
Your answer should be very brief. 1.05. What is the ratio of the Imports (BoP, current US$) in Myanmar in 2008 to that in 2009?
Give a very brief answer. 0.91. What is the ratio of the Imports (BoP, current US$) in Belarus in 2008 to that in 2010?
Provide a short and direct response. 1.11. What is the ratio of the Imports (BoP, current US$) of Faeroe Islands in 2008 to that in 2010?
Make the answer very short. 1.19. What is the ratio of the Imports (BoP, current US$) of Myanmar in 2008 to that in 2010?
Ensure brevity in your answer.  0.77. What is the ratio of the Imports (BoP, current US$) in Belarus in 2009 to that in 2010?
Offer a very short reply. 0.81. What is the ratio of the Imports (BoP, current US$) of Faeroe Islands in 2009 to that in 2010?
Provide a succinct answer. 0.99. What is the ratio of the Imports (BoP, current US$) in Malta in 2009 to that in 2010?
Your response must be concise. 0.95. What is the ratio of the Imports (BoP, current US$) of Myanmar in 2009 to that in 2010?
Your answer should be compact. 0.85. What is the difference between the highest and the second highest Imports (BoP, current US$) of Belarus?
Give a very brief answer. 4.07e+09. What is the difference between the highest and the second highest Imports (BoP, current US$) of Faeroe Islands?
Make the answer very short. 6.06e+06. What is the difference between the highest and the second highest Imports (BoP, current US$) in Malta?
Your answer should be very brief. 5.88e+07. What is the difference between the highest and the second highest Imports (BoP, current US$) in Myanmar?
Ensure brevity in your answer.  7.14e+08. What is the difference between the highest and the lowest Imports (BoP, current US$) in Belarus?
Keep it short and to the point. 2.37e+1. What is the difference between the highest and the lowest Imports (BoP, current US$) of Faeroe Islands?
Your response must be concise. 4.21e+08. What is the difference between the highest and the lowest Imports (BoP, current US$) of Malta?
Provide a succinct answer. 8.55e+09. What is the difference between the highest and the lowest Imports (BoP, current US$) of Myanmar?
Ensure brevity in your answer.  2.63e+09. 